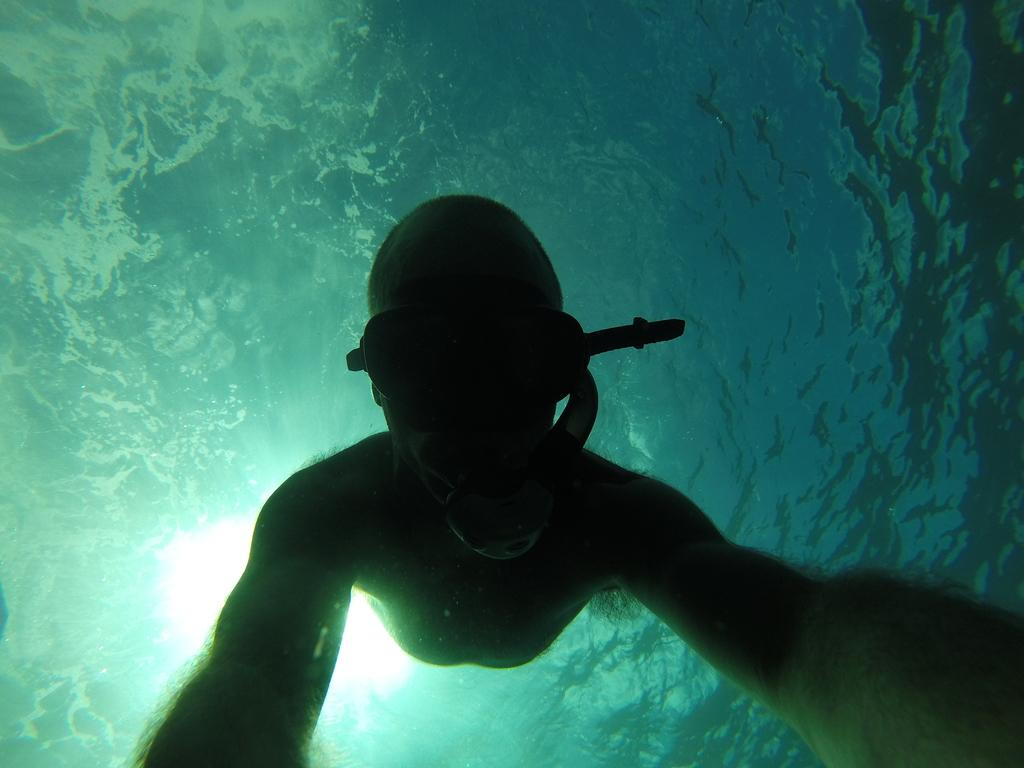What is the main subject of the image? There is a person in the image. Can you describe the person's location in the image? The person is inside the water. How many kittens are playing with a square object in the image? There are no kittens or square objects present in the image. What type of rat can be seen interacting with the person in the image? There is no rat present in the image; only the person is visible inside the water. 